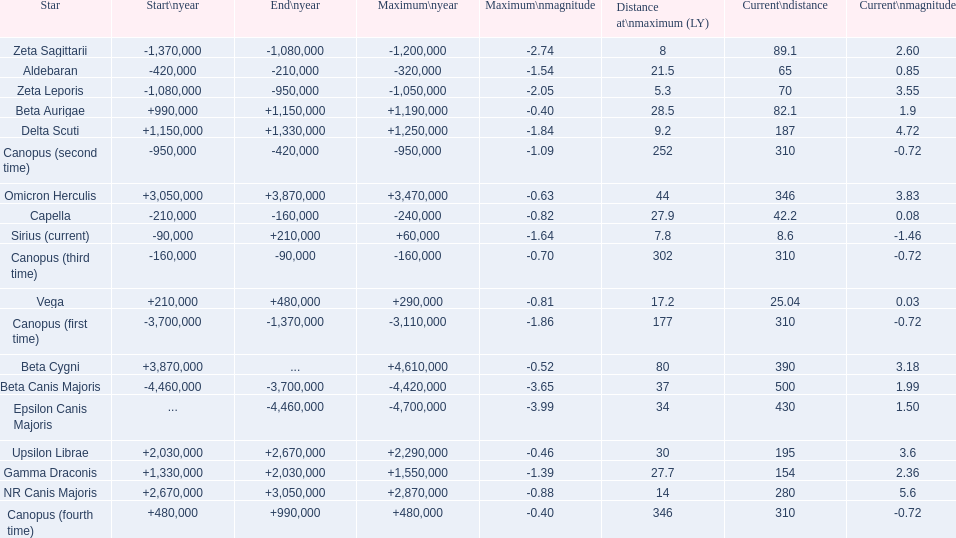What star has a a maximum magnitude of -0.63. Omicron Herculis. What star has a current distance of 390? Beta Cygni. 